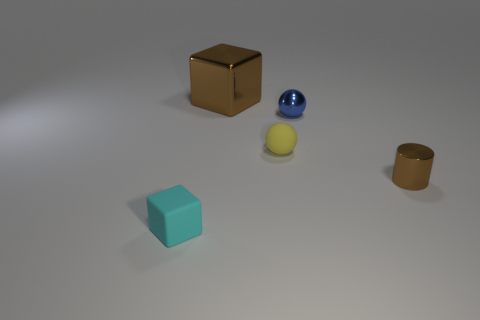Add 5 big blue metallic cylinders. How many objects exist? 10 Add 5 small cylinders. How many small cylinders are left? 6 Add 5 small spheres. How many small spheres exist? 7 Subtract all brown blocks. How many blocks are left? 1 Subtract 1 cyan blocks. How many objects are left? 4 Subtract all spheres. How many objects are left? 3 Subtract 1 blocks. How many blocks are left? 1 Subtract all red balls. Subtract all brown cubes. How many balls are left? 2 Subtract all green cubes. How many yellow spheres are left? 1 Subtract all cyan matte blocks. Subtract all tiny spheres. How many objects are left? 2 